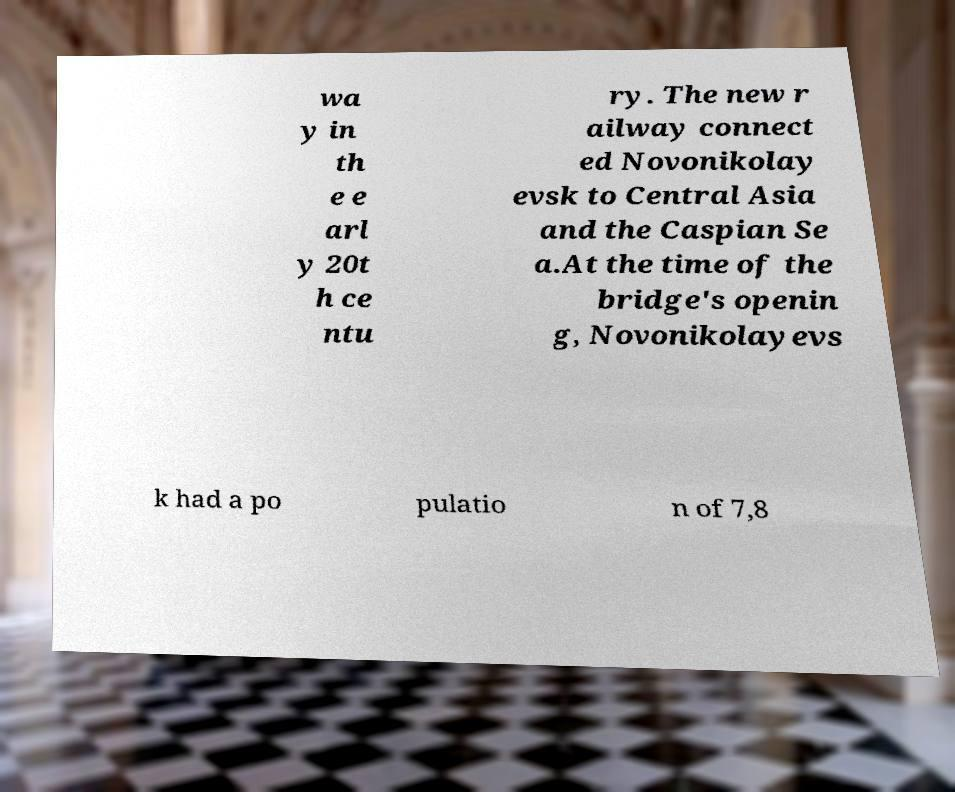I need the written content from this picture converted into text. Can you do that? wa y in th e e arl y 20t h ce ntu ry. The new r ailway connect ed Novonikolay evsk to Central Asia and the Caspian Se a.At the time of the bridge's openin g, Novonikolayevs k had a po pulatio n of 7,8 